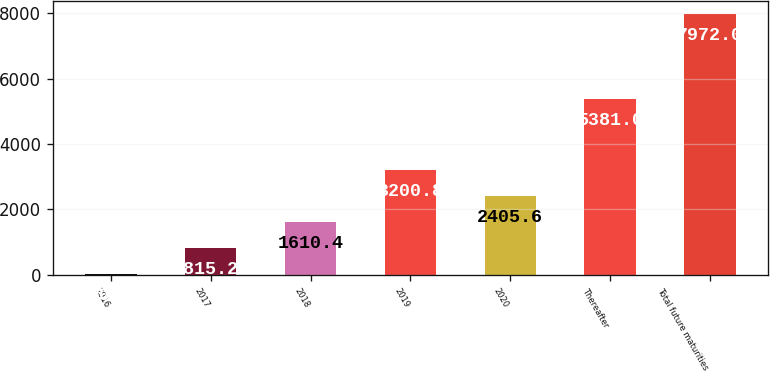<chart> <loc_0><loc_0><loc_500><loc_500><bar_chart><fcel>2016<fcel>2017<fcel>2018<fcel>2019<fcel>2020<fcel>Thereafter<fcel>Total future maturities<nl><fcel>20<fcel>815.2<fcel>1610.4<fcel>3200.8<fcel>2405.6<fcel>5381<fcel>7972<nl></chart> 